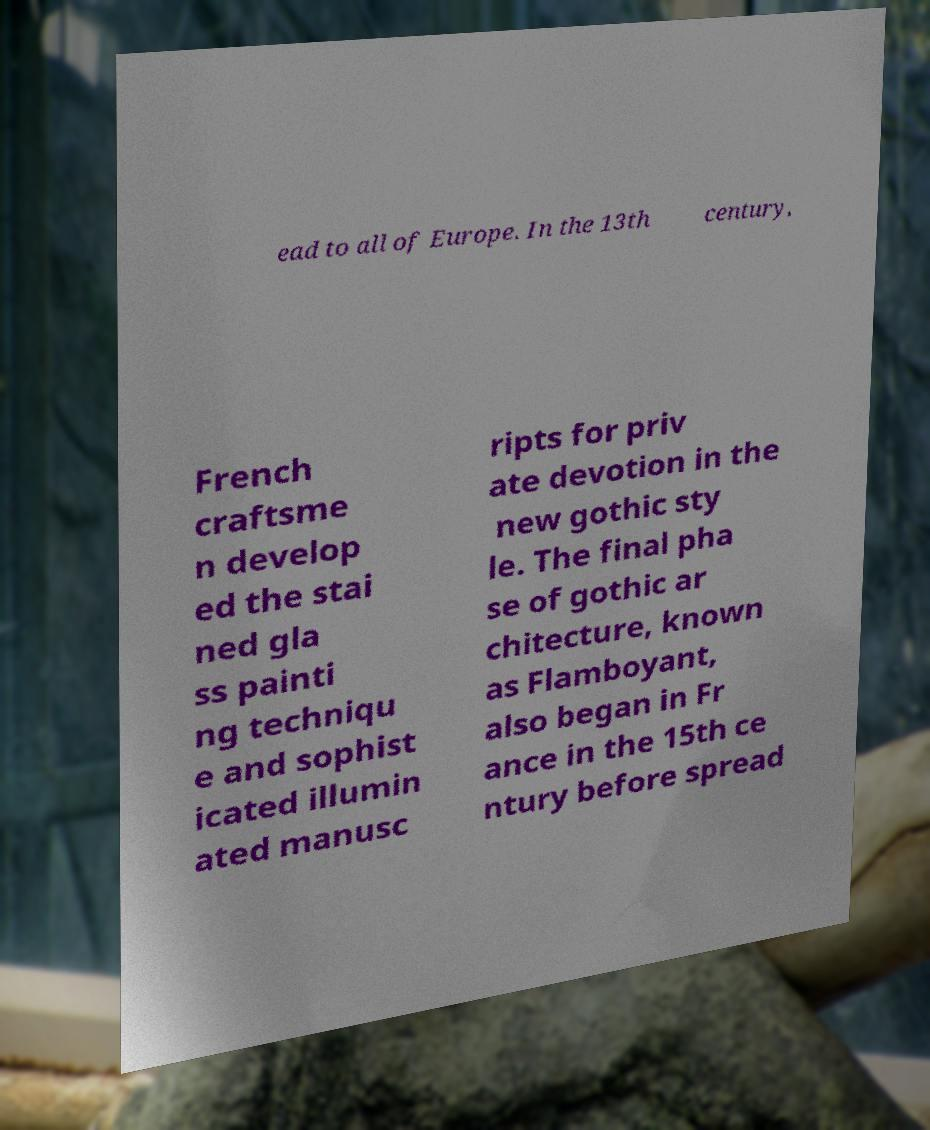Could you assist in decoding the text presented in this image and type it out clearly? ead to all of Europe. In the 13th century, French craftsme n develop ed the stai ned gla ss painti ng techniqu e and sophist icated illumin ated manusc ripts for priv ate devotion in the new gothic sty le. The final pha se of gothic ar chitecture, known as Flamboyant, also began in Fr ance in the 15th ce ntury before spread 